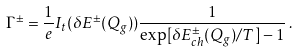Convert formula to latex. <formula><loc_0><loc_0><loc_500><loc_500>\Gamma ^ { \pm } = \frac { 1 } { e } I _ { t } ( \delta E ^ { \pm } ( Q _ { g } ) ) \frac { 1 } { \exp [ \delta E ^ { \pm } _ { c h } ( Q _ { g } ) / T ] - 1 } \, .</formula> 